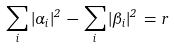<formula> <loc_0><loc_0><loc_500><loc_500>\sum _ { i } | \alpha _ { i } | ^ { 2 } \, - \, \sum _ { i } | \beta _ { i } | ^ { 2 } \, = \, r</formula> 